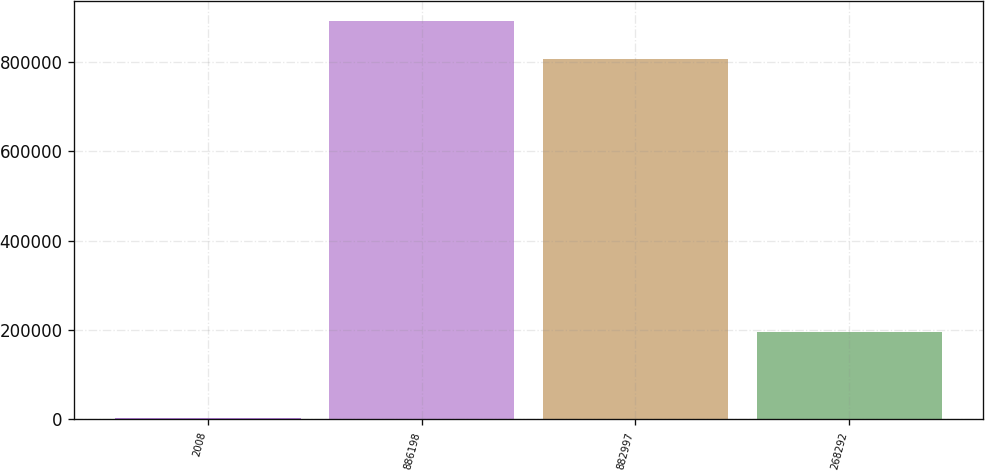<chart> <loc_0><loc_0><loc_500><loc_500><bar_chart><fcel>2008<fcel>886198<fcel>882997<fcel>268292<nl><fcel>2007<fcel>891051<fcel>806511<fcel>195835<nl></chart> 